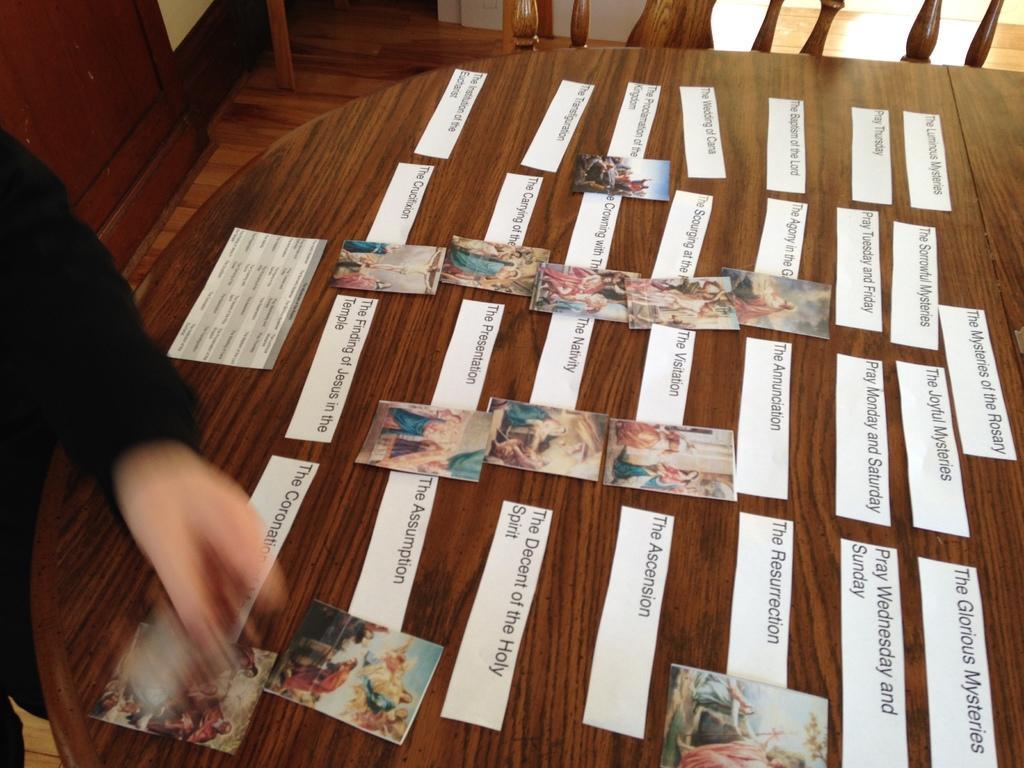Describe this image in one or two sentences. In this image, we can see some posters with text and images are placed on a table. We can also see some wooden objects. We can see the ground and an object on the top left corner. 